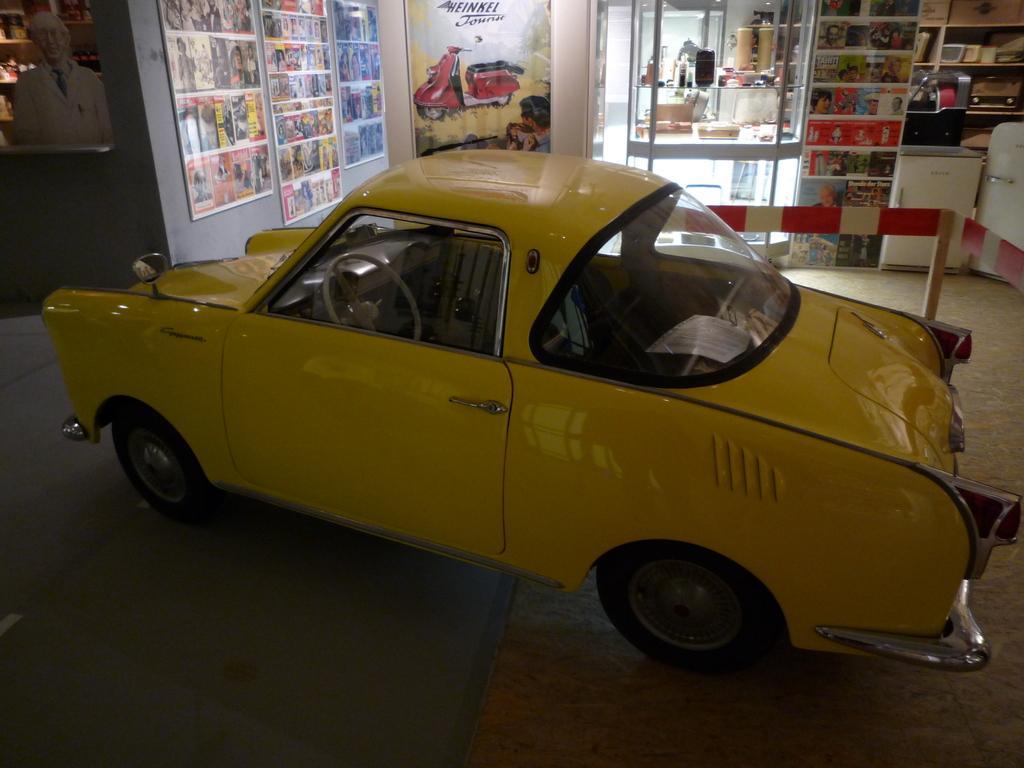Could you give a brief overview of what you see in this image? In this image, we can see a car. We can see the ground. We can see some posts with images and text. We can see the fence. We can see a table with some objects. We can see some shelves with objects. We can see white colored objects. We can see some glass. 